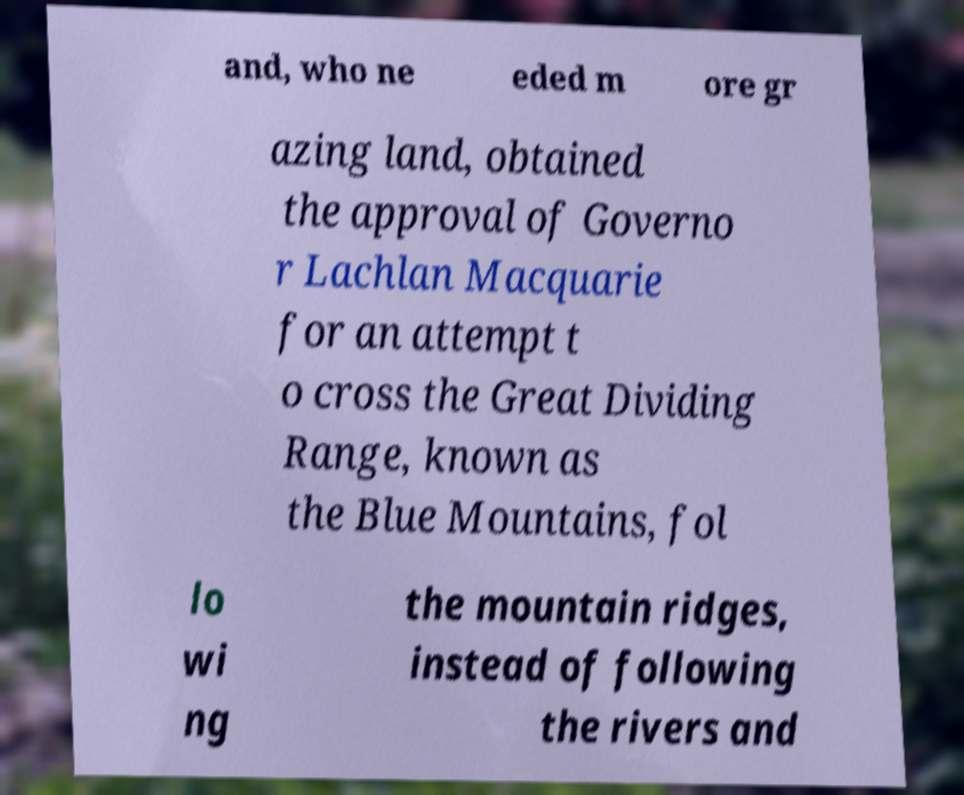Please read and relay the text visible in this image. What does it say? and, who ne eded m ore gr azing land, obtained the approval of Governo r Lachlan Macquarie for an attempt t o cross the Great Dividing Range, known as the Blue Mountains, fol lo wi ng the mountain ridges, instead of following the rivers and 